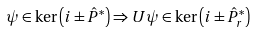Convert formula to latex. <formula><loc_0><loc_0><loc_500><loc_500>\psi \in \ker \left ( i \pm \hat { P } ^ { * } \right ) \Rightarrow U \psi \in \ker \left ( i \pm \hat { P } ^ { * } _ { r } \right )</formula> 